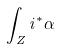<formula> <loc_0><loc_0><loc_500><loc_500>\int _ { Z } i ^ { * } \alpha</formula> 